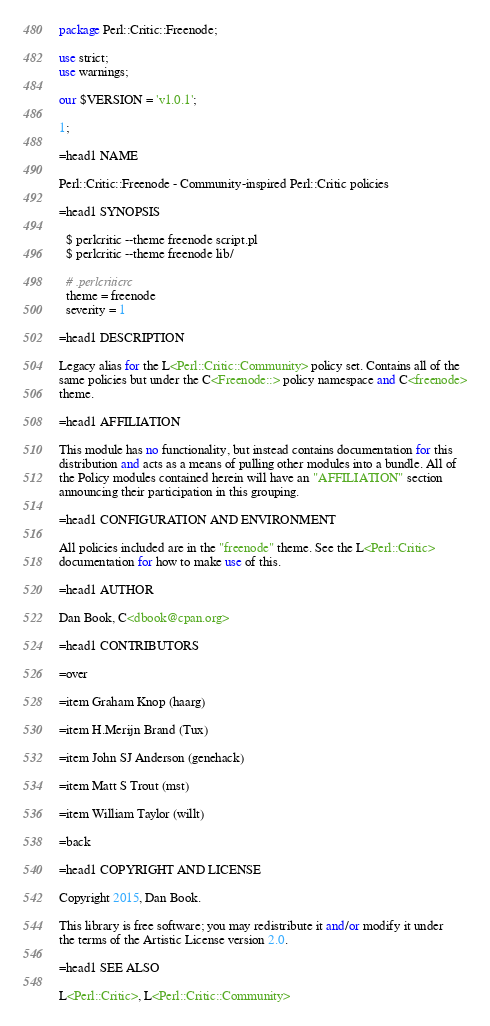Convert code to text. <code><loc_0><loc_0><loc_500><loc_500><_Perl_>package Perl::Critic::Freenode;

use strict;
use warnings;

our $VERSION = 'v1.0.1';

1;

=head1 NAME

Perl::Critic::Freenode - Community-inspired Perl::Critic policies

=head1 SYNOPSIS

  $ perlcritic --theme freenode script.pl
  $ perlcritic --theme freenode lib/
  
  # .perlcriticrc
  theme = freenode
  severity = 1

=head1 DESCRIPTION

Legacy alias for the L<Perl::Critic::Community> policy set. Contains all of the
same policies but under the C<Freenode::> policy namespace and C<freenode>
theme.

=head1 AFFILIATION

This module has no functionality, but instead contains documentation for this
distribution and acts as a means of pulling other modules into a bundle. All of
the Policy modules contained herein will have an "AFFILIATION" section
announcing their participation in this grouping.

=head1 CONFIGURATION AND ENVIRONMENT

All policies included are in the "freenode" theme. See the L<Perl::Critic>
documentation for how to make use of this.

=head1 AUTHOR

Dan Book, C<dbook@cpan.org>

=head1 CONTRIBUTORS

=over

=item Graham Knop (haarg)

=item H.Merijn Brand (Tux)

=item John SJ Anderson (genehack)

=item Matt S Trout (mst)

=item William Taylor (willt)

=back

=head1 COPYRIGHT AND LICENSE

Copyright 2015, Dan Book.

This library is free software; you may redistribute it and/or modify it under
the terms of the Artistic License version 2.0.

=head1 SEE ALSO

L<Perl::Critic>, L<Perl::Critic::Community>
</code> 